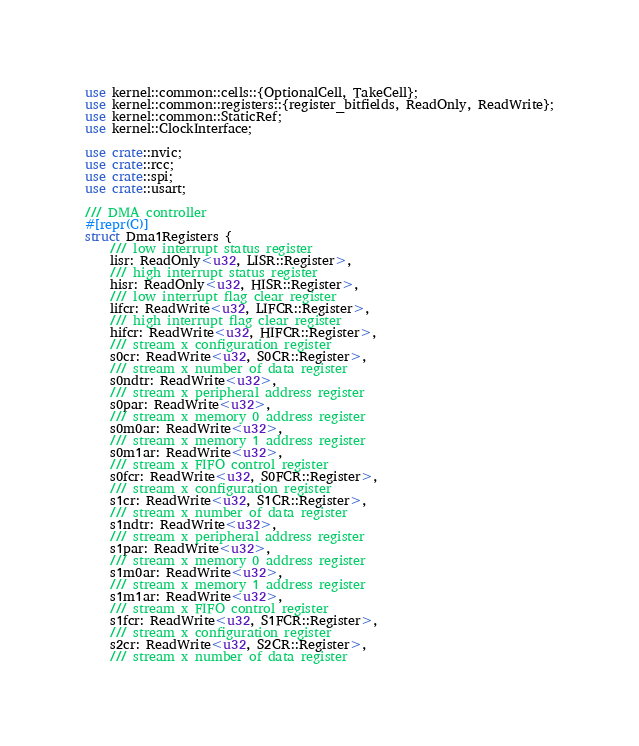<code> <loc_0><loc_0><loc_500><loc_500><_Rust_>use kernel::common::cells::{OptionalCell, TakeCell};
use kernel::common::registers::{register_bitfields, ReadOnly, ReadWrite};
use kernel::common::StaticRef;
use kernel::ClockInterface;

use crate::nvic;
use crate::rcc;
use crate::spi;
use crate::usart;

/// DMA controller
#[repr(C)]
struct Dma1Registers {
    /// low interrupt status register
    lisr: ReadOnly<u32, LISR::Register>,
    /// high interrupt status register
    hisr: ReadOnly<u32, HISR::Register>,
    /// low interrupt flag clear register
    lifcr: ReadWrite<u32, LIFCR::Register>,
    /// high interrupt flag clear register
    hifcr: ReadWrite<u32, HIFCR::Register>,
    /// stream x configuration register
    s0cr: ReadWrite<u32, S0CR::Register>,
    /// stream x number of data register
    s0ndtr: ReadWrite<u32>,
    /// stream x peripheral address register
    s0par: ReadWrite<u32>,
    /// stream x memory 0 address register
    s0m0ar: ReadWrite<u32>,
    /// stream x memory 1 address register
    s0m1ar: ReadWrite<u32>,
    /// stream x FIFO control register
    s0fcr: ReadWrite<u32, S0FCR::Register>,
    /// stream x configuration register
    s1cr: ReadWrite<u32, S1CR::Register>,
    /// stream x number of data register
    s1ndtr: ReadWrite<u32>,
    /// stream x peripheral address register
    s1par: ReadWrite<u32>,
    /// stream x memory 0 address register
    s1m0ar: ReadWrite<u32>,
    /// stream x memory 1 address register
    s1m1ar: ReadWrite<u32>,
    /// stream x FIFO control register
    s1fcr: ReadWrite<u32, S1FCR::Register>,
    /// stream x configuration register
    s2cr: ReadWrite<u32, S2CR::Register>,
    /// stream x number of data register</code> 